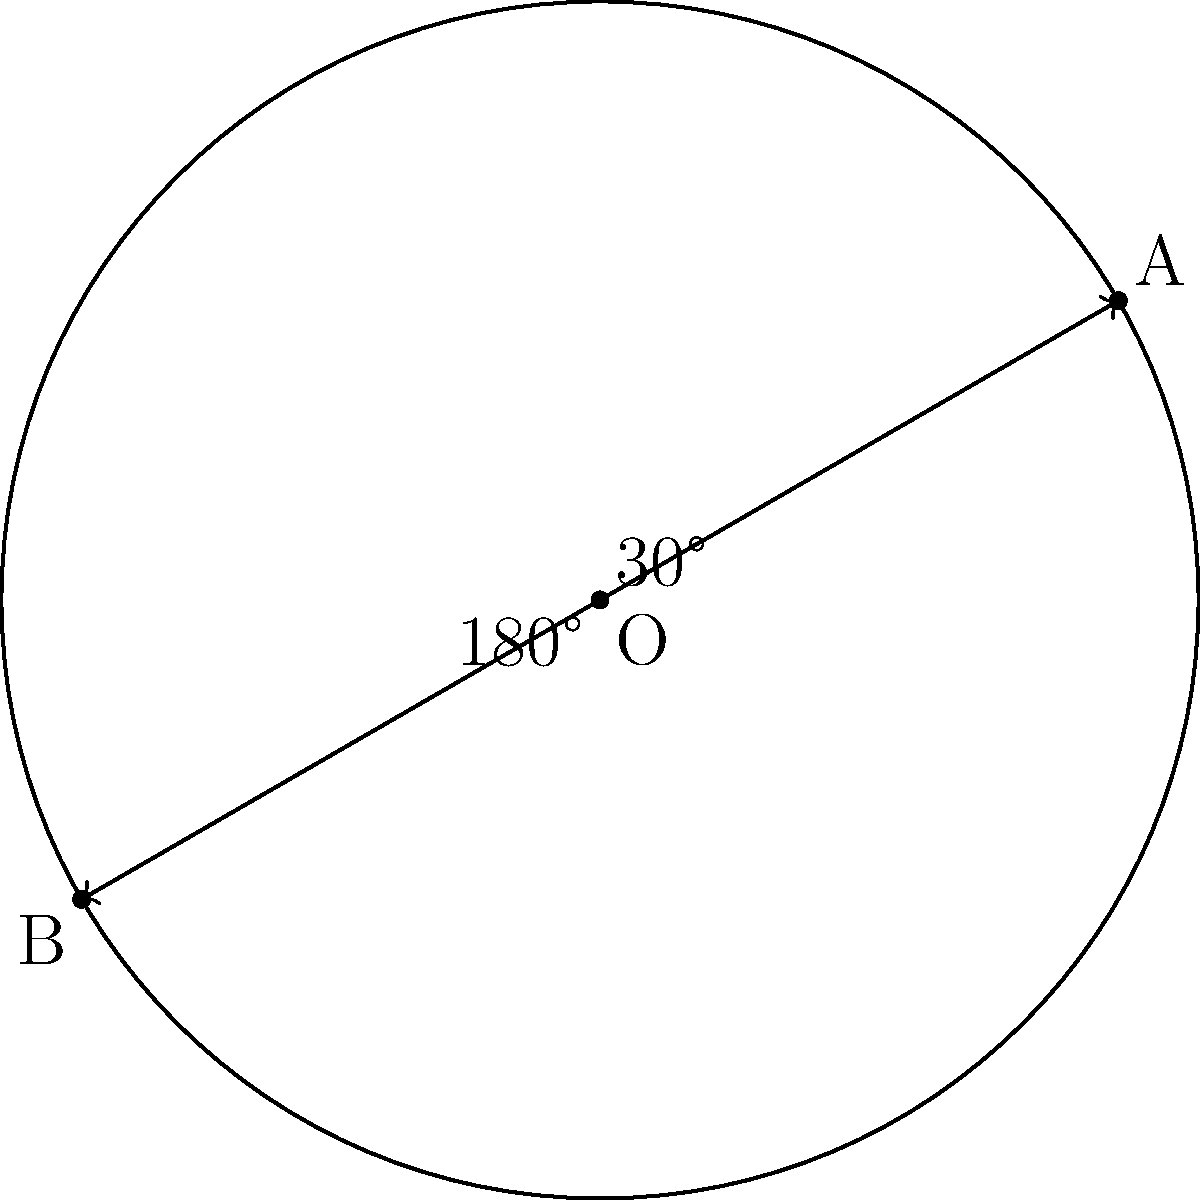In a circular plasmid DNA with a radius of 3 μm, two genes of interest are located at points A and B. Point A is at a 30° angle from the positive x-axis, and point B is at a 210° angle. Calculate the shortest distance between these two genes along the circular DNA. To solve this problem, we need to follow these steps:

1) First, we need to calculate the arc length between points A and B. The central angle between these points is:
   $210° - 30° = 180°$

2) The arc length formula is:
   $s = r\theta$
   where $s$ is the arc length, $r$ is the radius, and $\theta$ is the central angle in radians.

3) Convert 180° to radians:
   $180° \times \frac{\pi}{180°} = \pi$ radians

4) Now we can calculate the arc length:
   $s = 3 \mu m \times \pi = 3\pi \mu m$

5) This is the longest path between A and B. The shortest path is the straight line distance between these points, which forms a chord of the circle.

6) To find the chord length, we can use the formula:
   $chord = 2r \sin(\frac{\theta}{2})$

7) Substituting our values:
   $chord = 2 \times 3 \mu m \times \sin(\frac{\pi}{2}) = 6 \mu m$

Therefore, the shortest distance between the two genes along the circular DNA is 6 μm.
Answer: 6 μm 